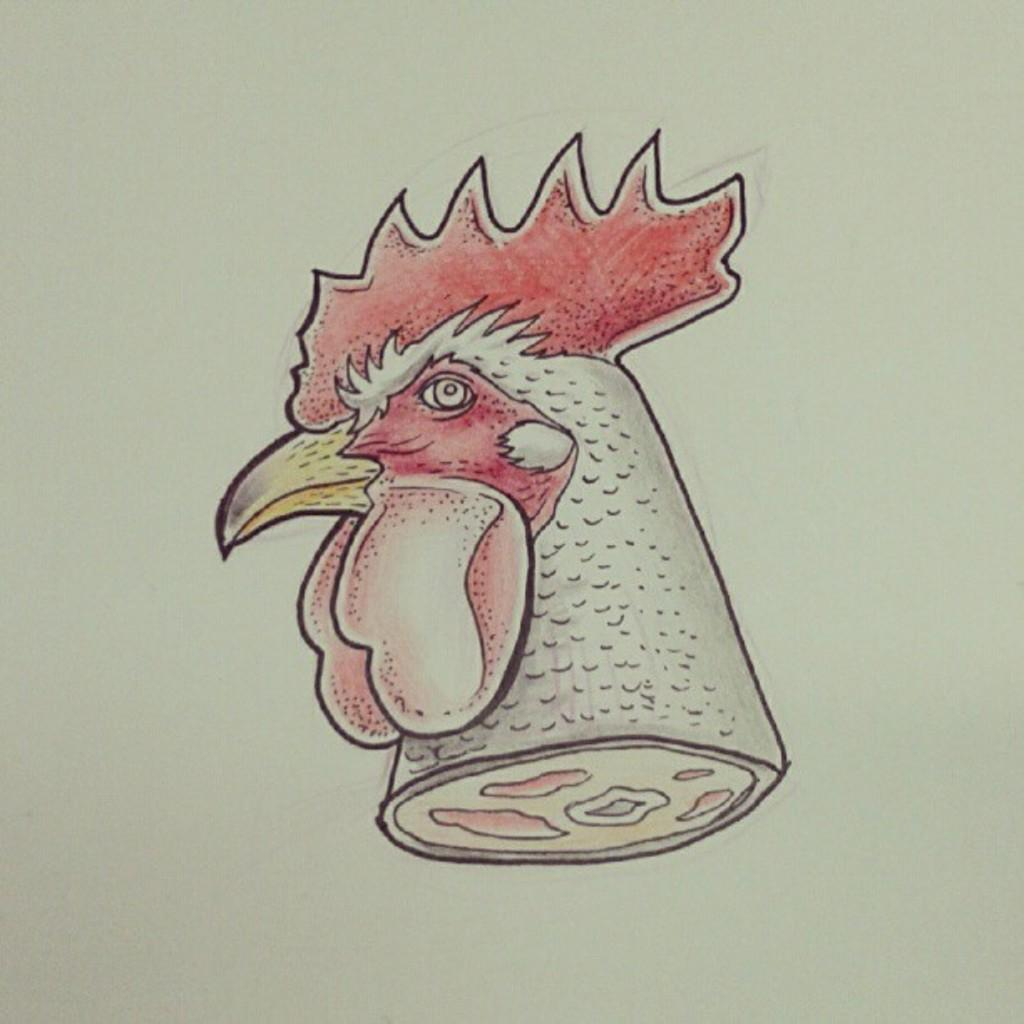What is the main subject of the image? The main subject of the image is a sketch of a cock's head. How many holes can be seen in the sketch of the cock's head? There are no holes present in the sketch of the cock's head; it is a drawing of a cock's head. 